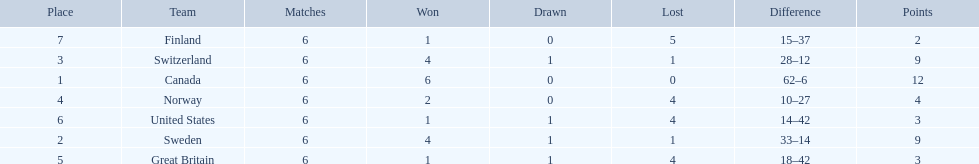Which country performed better during the 1951 world ice hockey championships, switzerland or great britain? Switzerland. 